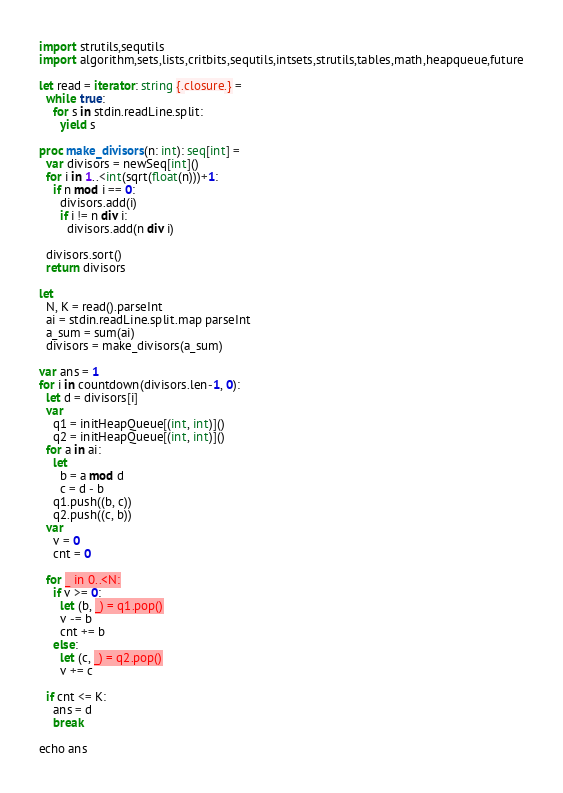Convert code to text. <code><loc_0><loc_0><loc_500><loc_500><_Nim_>import strutils,sequtils
import algorithm,sets,lists,critbits,sequtils,intsets,strutils,tables,math,heapqueue,future

let read = iterator: string {.closure.} =
  while true:
    for s in stdin.readLine.split:
      yield s

proc make_divisors(n: int): seq[int] = 
  var divisors = newSeq[int]()
  for i in 1..<int(sqrt(float(n)))+1:
    if n mod i == 0:
      divisors.add(i)
      if i != n div i:
        divisors.add(n div i)

  divisors.sort()
  return divisors

let
  N, K = read().parseInt
  ai = stdin.readLine.split.map parseInt
  a_sum = sum(ai)
  divisors = make_divisors(a_sum)

var ans = 1
for i in countdown(divisors.len-1, 0):
  let d = divisors[i]
  var
    q1 = initHeapQueue[(int, int)]()
    q2 = initHeapQueue[(int, int)]()
  for a in ai:
    let
      b = a mod d
      c = d - b
    q1.push((b, c))
    q2.push((c, b))
  var
    v = 0
    cnt = 0
  
  for _ in 0..<N:
    if v >= 0:
      let (b, _) = q1.pop()
      v -= b
      cnt += b
    else:
      let (c, _) = q2.pop()
      v += c

  if cnt <= K:
    ans = d
    break

echo ans
</code> 